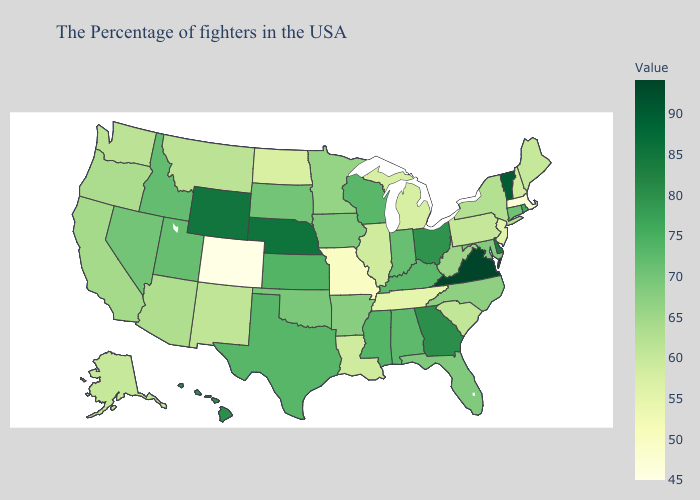Among the states that border Washington , does Idaho have the lowest value?
Quick response, please. No. Does Alaska have a higher value than Ohio?
Concise answer only. No. Does the map have missing data?
Keep it brief. No. 